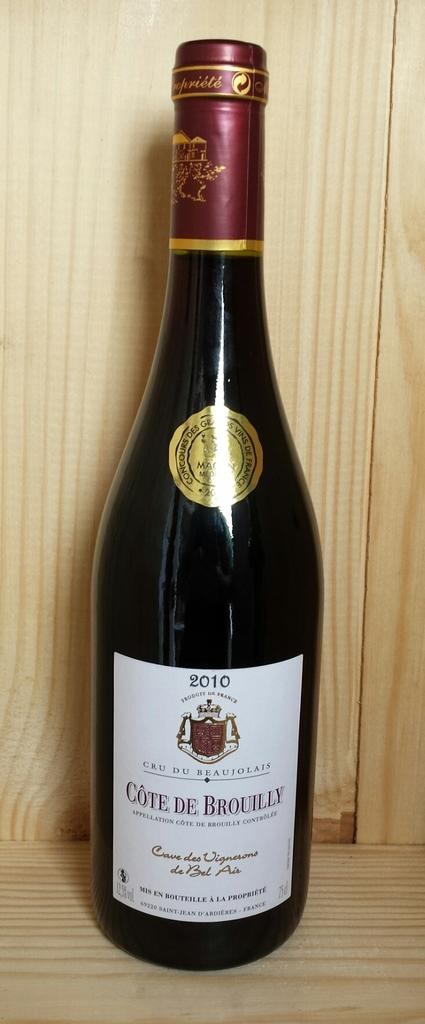<image>
Offer a succinct explanation of the picture presented. A 2010 bottle of Cote de Brouilly that was bottled in France. 